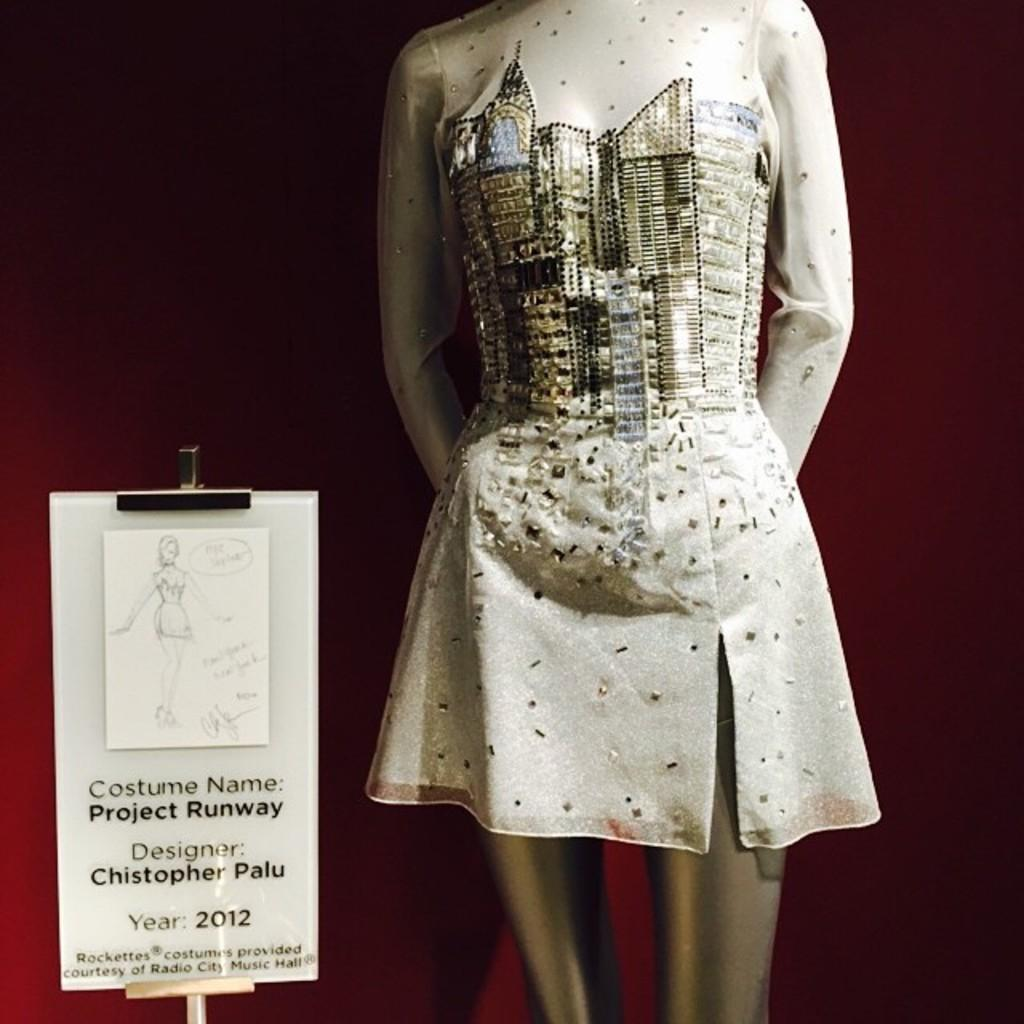What is featured in the image related to a doll? There is a dress for a doll in the image. What can be seen on the left side of the image? There is a board on the left side of the image. What information does the board provide about the dress? The board describes the dress. What type of tank is visible in the image? There is no tank present in the image. How many crackers are placed on the board in the image? There are no crackers present in the image; the board describes a dress for a doll. 